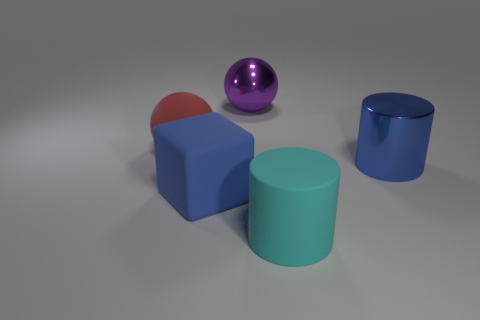What number of big blue metal objects are the same shape as the large cyan thing?
Your answer should be compact. 1. How many purple spheres have the same size as the blue cube?
Provide a succinct answer. 1. There is a big purple object that is the same shape as the big red object; what material is it?
Provide a succinct answer. Metal. What is the color of the big metallic object in front of the large purple shiny object?
Ensure brevity in your answer.  Blue. Is the number of matte balls behind the large cyan thing greater than the number of gray rubber cubes?
Offer a terse response. Yes. What is the color of the big block?
Provide a short and direct response. Blue. There is a big matte object behind the blue object in front of the blue metallic cylinder that is to the right of the big matte block; what is its shape?
Make the answer very short. Sphere. What is the material of the large thing that is both in front of the big blue shiny cylinder and left of the cyan rubber cylinder?
Ensure brevity in your answer.  Rubber. There is a big blue shiny thing that is to the right of the big cylinder in front of the large shiny cylinder; what shape is it?
Offer a very short reply. Cylinder. Is there any other thing of the same color as the large matte ball?
Your answer should be compact. No. 